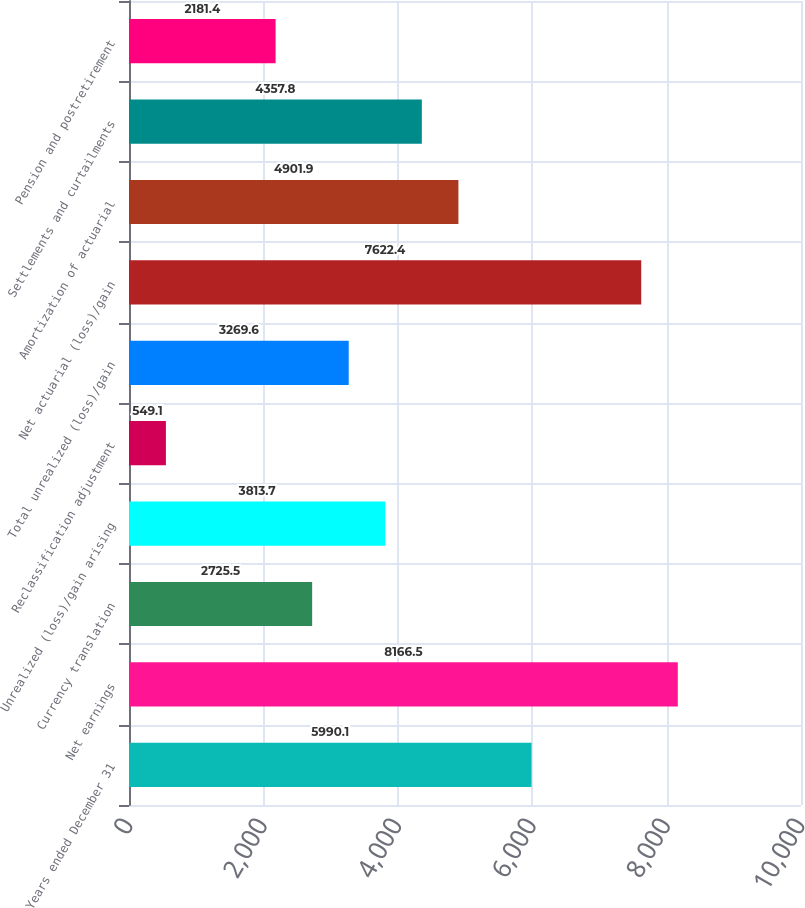<chart> <loc_0><loc_0><loc_500><loc_500><bar_chart><fcel>Years ended December 31<fcel>Net earnings<fcel>Currency translation<fcel>Unrealized (loss)/gain arising<fcel>Reclassification adjustment<fcel>Total unrealized (loss)/gain<fcel>Net actuarial (loss)/gain<fcel>Amortization of actuarial<fcel>Settlements and curtailments<fcel>Pension and postretirement<nl><fcel>5990.1<fcel>8166.5<fcel>2725.5<fcel>3813.7<fcel>549.1<fcel>3269.6<fcel>7622.4<fcel>4901.9<fcel>4357.8<fcel>2181.4<nl></chart> 